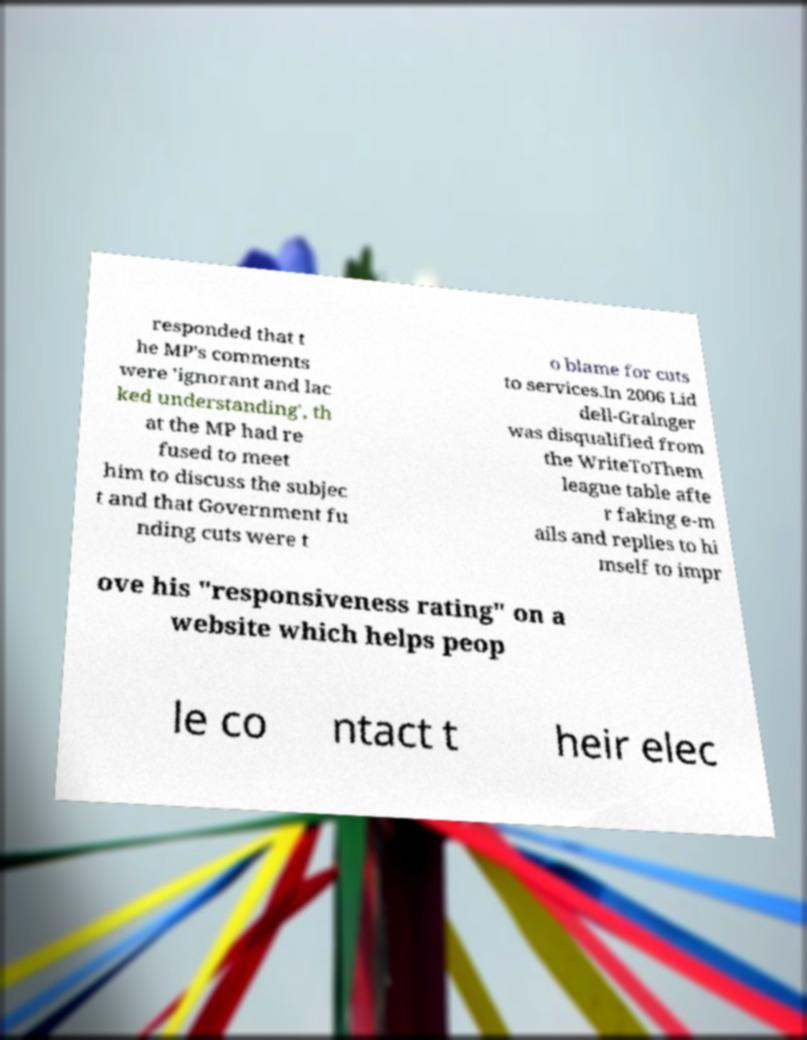Could you assist in decoding the text presented in this image and type it out clearly? responded that t he MP's comments were 'ignorant and lac ked understanding', th at the MP had re fused to meet him to discuss the subjec t and that Government fu nding cuts were t o blame for cuts to services.In 2006 Lid dell-Grainger was disqualified from the WriteToThem league table afte r faking e-m ails and replies to hi mself to impr ove his "responsiveness rating" on a website which helps peop le co ntact t heir elec 